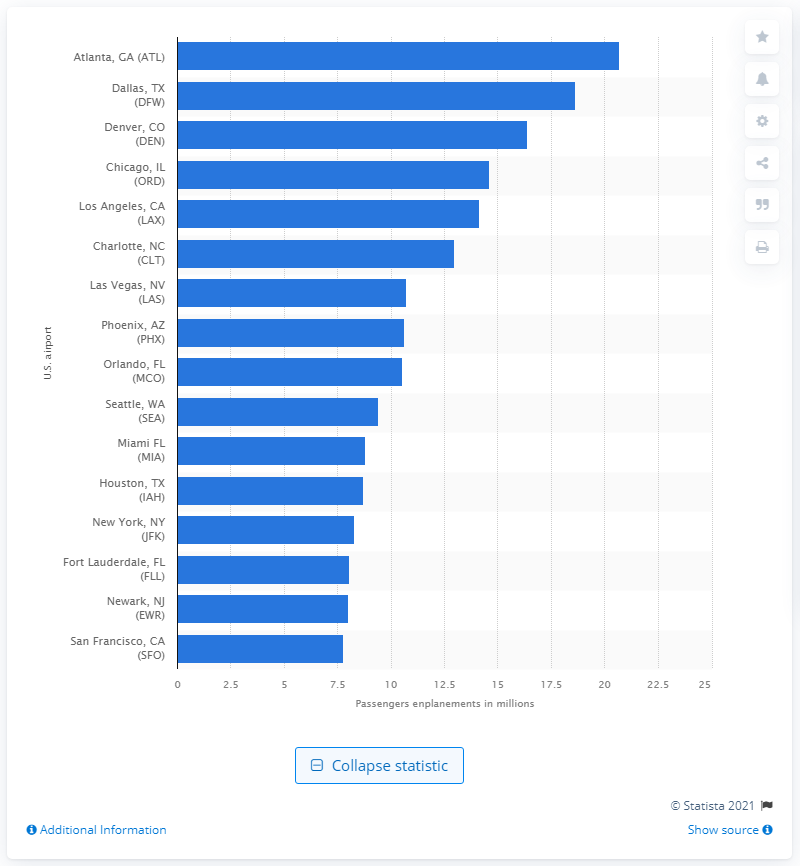Identify some key points in this picture. In 2020, Atlanta International Airport transported a total of 20,710 passengers. 